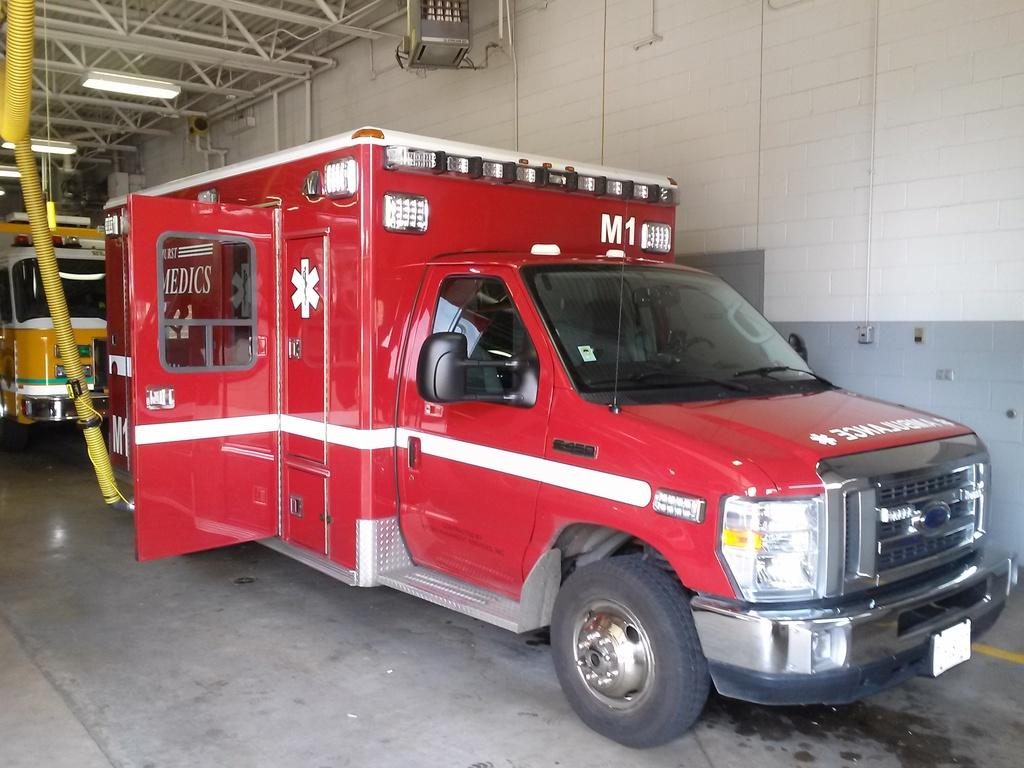What is on the floor in the image? There are vehicles on the floor in the image. What can be seen in the background of the image? There is a wall visible in the background of the image, as well as other unspecified objects. What is present on the ceiling in the image? There are lights on the ceiling in the image. What direction are the vehicles facing in the image? The provided facts do not specify the direction the vehicles are facing, so it cannot be determined from the image. 